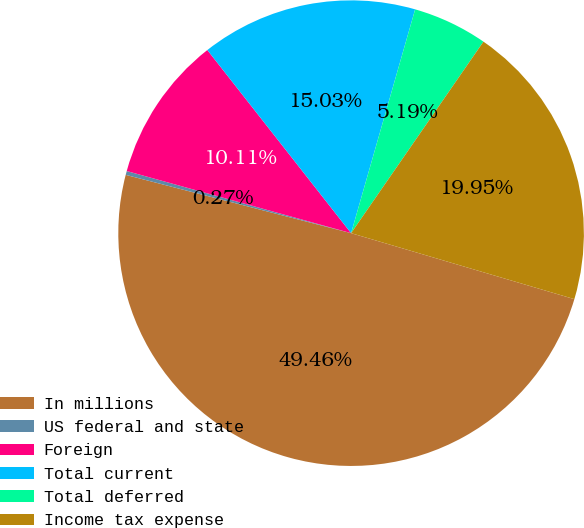<chart> <loc_0><loc_0><loc_500><loc_500><pie_chart><fcel>In millions<fcel>US federal and state<fcel>Foreign<fcel>Total current<fcel>Total deferred<fcel>Income tax expense<nl><fcel>49.46%<fcel>0.27%<fcel>10.11%<fcel>15.03%<fcel>5.19%<fcel>19.95%<nl></chart> 